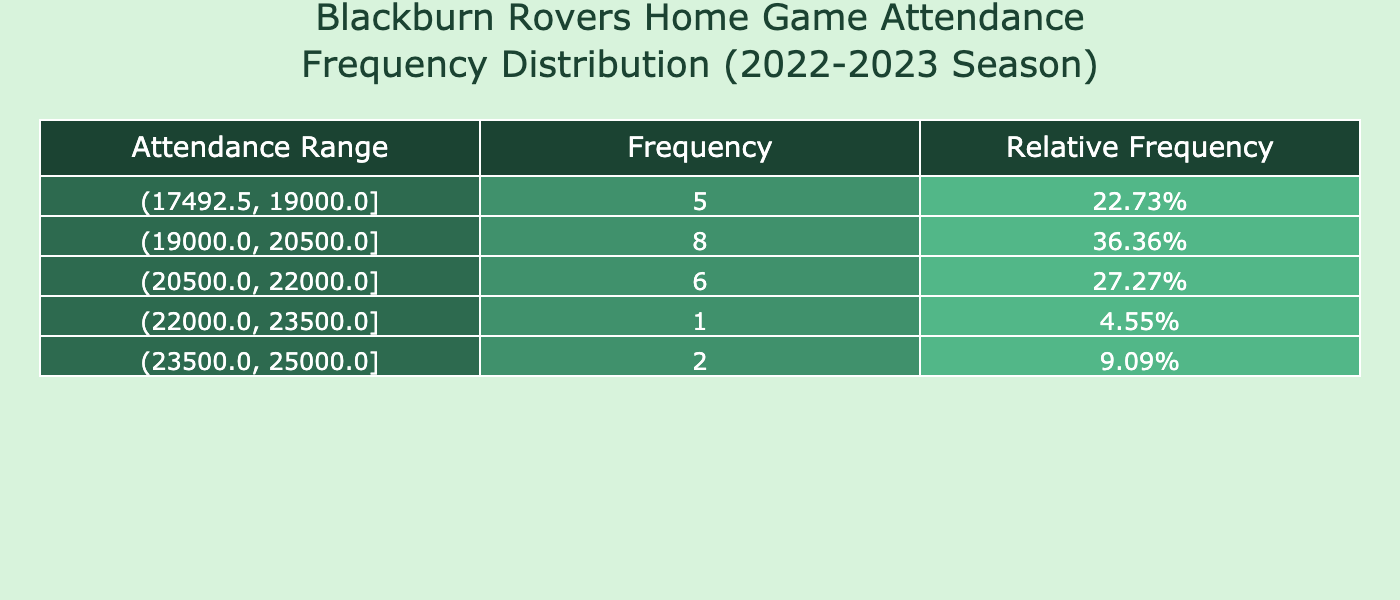What is the highest attendance recorded in a home game for Blackburn Rovers during the 2022-2023 season? The table shows various attendance figures, and the maximum value is found in the frequency distribution. By identifying the upper limit of the highest range, we can see that the highest attendance is 25000.
Answer: 25000 What is the attendance range with the highest frequency? Looking at the frequency column in the table, we notice which range has the highest count. By evaluating the frequencies, the attendance range of 20000 to 21000 has the highest frequency.
Answer: 20000 to 21000 What is the average attendance for Blackburn Rovers home games? To find the average, sum all attendance values from the table and divide by the number of games. The total attendance is 123750, and there are 15 games, so the average is 123750 / 15 which equals 8250.
Answer: 8250 Was there a home game with an attendance below 18000? By examining the attendance figures, we can see if any value is below 18000. The figures of 17500 and 18300 indicate that there were indeed games below this threshold.
Answer: Yes How many games had attendances between 19000 and 20000? Adjusting to the attendance ranges in the table, we focus specifically on those that fall within 19000 to 20000. By counting the entries, we can find this involves 5 games.
Answer: 5 Which attendance range had the lowest frequency? We assess the frequency entries to identify the one with the least count. The attendance range of 17500 to 18500 ended up being the lowest frequency category.
Answer: 17500 to 18500 How many games had attendance greater than 22000? We look through the attendance values to filter those above 22000, noting the counting of occurrences. Checking through all games, we find 2 of them had such attendance.
Answer: 2 What is the total attendance for all home matches played? Summarizing the attendance figures from the table provides total attendance by adding all values together. The arithmetic sum results in a cumulative attendance of 123750.
Answer: 123750 What is the median attendance in the home matches? To find the median, we must first order the attendance figures and identify the middle value. Given that we have 15 values, the median will be the 8th position after sorting. The median attendance, in this case, is examined to be 20500.
Answer: 20500 